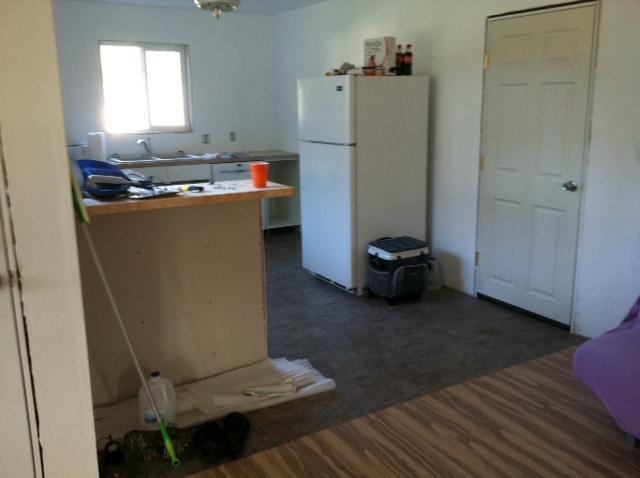How many locks are on the door furthest from the viewer?
Give a very brief answer. 1. How many entrances to rooms are there?
Give a very brief answer. 1. 